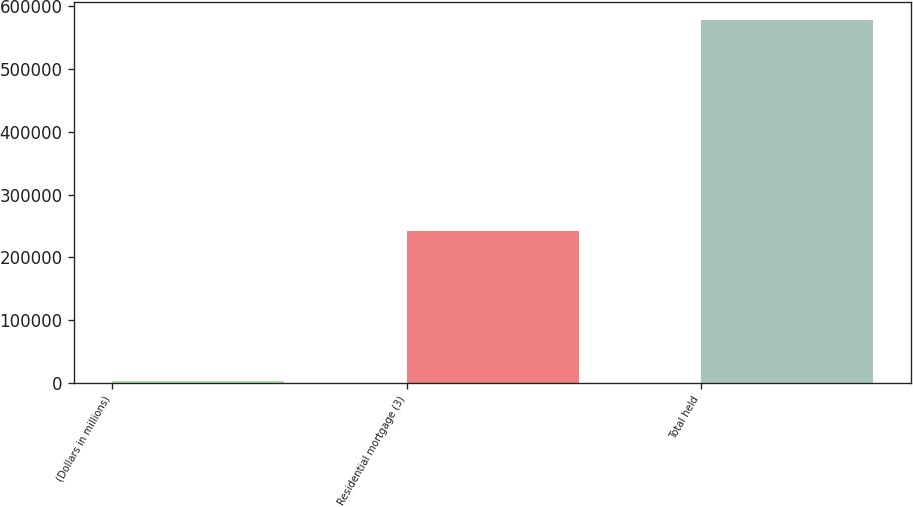Convert chart. <chart><loc_0><loc_0><loc_500><loc_500><bar_chart><fcel>(Dollars in millions)<fcel>Residential mortgage (3)<fcel>Total held<nl><fcel>2009<fcel>242129<fcel>577564<nl></chart> 